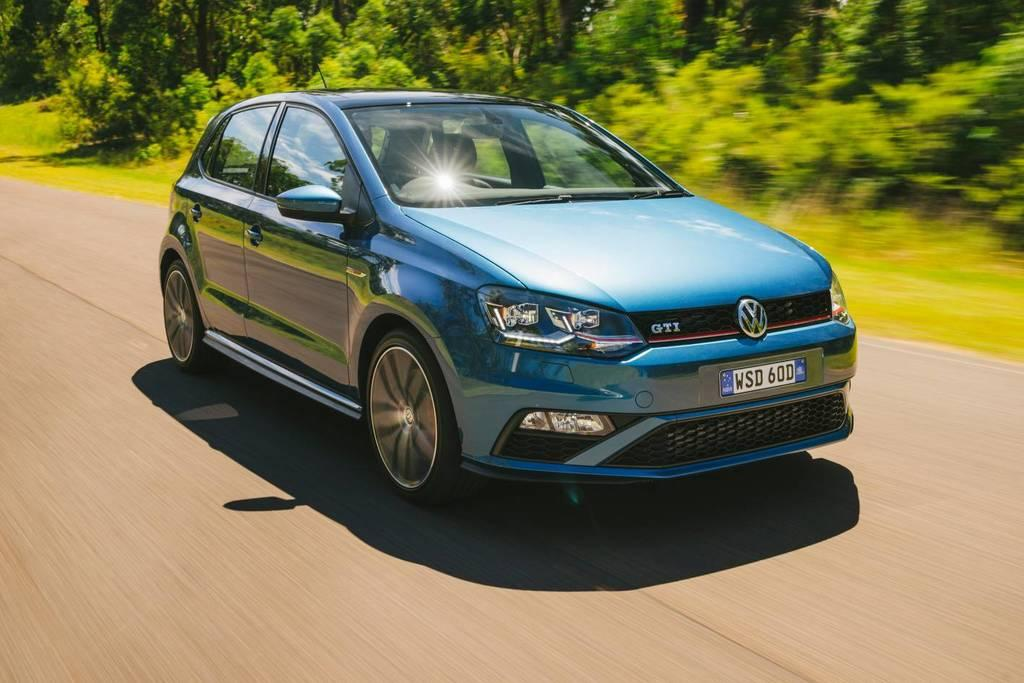What is the main subject of the image? The main subject of the image is a car. What color is the car? The car is blue in color. What is the car doing in the image? The car is moving on a road. What can be seen in the background of the image? There are trees in the background of the image. Are there any giants visible in the image? No, there are no giants present in the image. What type of wilderness can be seen in the background of the image? There is no wilderness visible in the image; it features a car moving on a road with trees in the background. 